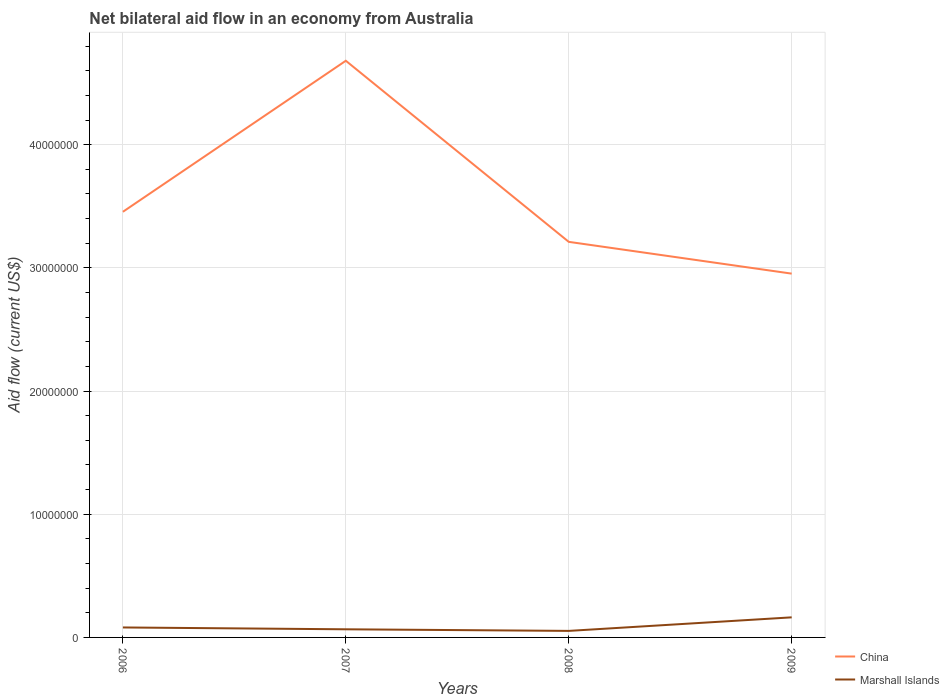Does the line corresponding to Marshall Islands intersect with the line corresponding to China?
Provide a short and direct response. No. Across all years, what is the maximum net bilateral aid flow in China?
Provide a short and direct response. 2.95e+07. What is the total net bilateral aid flow in Marshall Islands in the graph?
Make the answer very short. -1.10e+06. What is the difference between the highest and the second highest net bilateral aid flow in Marshall Islands?
Your response must be concise. 1.10e+06. How many lines are there?
Make the answer very short. 2. How many years are there in the graph?
Your answer should be compact. 4. What is the difference between two consecutive major ticks on the Y-axis?
Offer a very short reply. 1.00e+07. Does the graph contain any zero values?
Your response must be concise. No. How many legend labels are there?
Provide a succinct answer. 2. How are the legend labels stacked?
Your response must be concise. Vertical. What is the title of the graph?
Your response must be concise. Net bilateral aid flow in an economy from Australia. Does "Oman" appear as one of the legend labels in the graph?
Provide a short and direct response. No. What is the label or title of the X-axis?
Offer a terse response. Years. What is the Aid flow (current US$) of China in 2006?
Keep it short and to the point. 3.46e+07. What is the Aid flow (current US$) in Marshall Islands in 2006?
Keep it short and to the point. 8.10e+05. What is the Aid flow (current US$) in China in 2007?
Your answer should be very brief. 4.68e+07. What is the Aid flow (current US$) in Marshall Islands in 2007?
Offer a very short reply. 6.60e+05. What is the Aid flow (current US$) in China in 2008?
Provide a succinct answer. 3.21e+07. What is the Aid flow (current US$) in Marshall Islands in 2008?
Make the answer very short. 5.30e+05. What is the Aid flow (current US$) of China in 2009?
Your answer should be very brief. 2.95e+07. What is the Aid flow (current US$) of Marshall Islands in 2009?
Your answer should be very brief. 1.63e+06. Across all years, what is the maximum Aid flow (current US$) of China?
Your answer should be compact. 4.68e+07. Across all years, what is the maximum Aid flow (current US$) in Marshall Islands?
Keep it short and to the point. 1.63e+06. Across all years, what is the minimum Aid flow (current US$) of China?
Your response must be concise. 2.95e+07. Across all years, what is the minimum Aid flow (current US$) of Marshall Islands?
Give a very brief answer. 5.30e+05. What is the total Aid flow (current US$) in China in the graph?
Make the answer very short. 1.43e+08. What is the total Aid flow (current US$) in Marshall Islands in the graph?
Give a very brief answer. 3.63e+06. What is the difference between the Aid flow (current US$) of China in 2006 and that in 2007?
Your answer should be very brief. -1.23e+07. What is the difference between the Aid flow (current US$) of China in 2006 and that in 2008?
Give a very brief answer. 2.44e+06. What is the difference between the Aid flow (current US$) of Marshall Islands in 2006 and that in 2008?
Offer a very short reply. 2.80e+05. What is the difference between the Aid flow (current US$) of China in 2006 and that in 2009?
Give a very brief answer. 5.02e+06. What is the difference between the Aid flow (current US$) of Marshall Islands in 2006 and that in 2009?
Make the answer very short. -8.20e+05. What is the difference between the Aid flow (current US$) in China in 2007 and that in 2008?
Provide a short and direct response. 1.47e+07. What is the difference between the Aid flow (current US$) in Marshall Islands in 2007 and that in 2008?
Make the answer very short. 1.30e+05. What is the difference between the Aid flow (current US$) in China in 2007 and that in 2009?
Make the answer very short. 1.73e+07. What is the difference between the Aid flow (current US$) of Marshall Islands in 2007 and that in 2009?
Provide a short and direct response. -9.70e+05. What is the difference between the Aid flow (current US$) of China in 2008 and that in 2009?
Provide a succinct answer. 2.58e+06. What is the difference between the Aid flow (current US$) in Marshall Islands in 2008 and that in 2009?
Your answer should be very brief. -1.10e+06. What is the difference between the Aid flow (current US$) of China in 2006 and the Aid flow (current US$) of Marshall Islands in 2007?
Make the answer very short. 3.39e+07. What is the difference between the Aid flow (current US$) of China in 2006 and the Aid flow (current US$) of Marshall Islands in 2008?
Give a very brief answer. 3.40e+07. What is the difference between the Aid flow (current US$) of China in 2006 and the Aid flow (current US$) of Marshall Islands in 2009?
Offer a terse response. 3.29e+07. What is the difference between the Aid flow (current US$) in China in 2007 and the Aid flow (current US$) in Marshall Islands in 2008?
Your response must be concise. 4.63e+07. What is the difference between the Aid flow (current US$) of China in 2007 and the Aid flow (current US$) of Marshall Islands in 2009?
Your answer should be compact. 4.52e+07. What is the difference between the Aid flow (current US$) in China in 2008 and the Aid flow (current US$) in Marshall Islands in 2009?
Your answer should be very brief. 3.05e+07. What is the average Aid flow (current US$) in China per year?
Your answer should be very brief. 3.58e+07. What is the average Aid flow (current US$) of Marshall Islands per year?
Provide a short and direct response. 9.08e+05. In the year 2006, what is the difference between the Aid flow (current US$) in China and Aid flow (current US$) in Marshall Islands?
Keep it short and to the point. 3.37e+07. In the year 2007, what is the difference between the Aid flow (current US$) of China and Aid flow (current US$) of Marshall Islands?
Offer a very short reply. 4.62e+07. In the year 2008, what is the difference between the Aid flow (current US$) in China and Aid flow (current US$) in Marshall Islands?
Your response must be concise. 3.16e+07. In the year 2009, what is the difference between the Aid flow (current US$) of China and Aid flow (current US$) of Marshall Islands?
Your response must be concise. 2.79e+07. What is the ratio of the Aid flow (current US$) of China in 2006 to that in 2007?
Your answer should be compact. 0.74. What is the ratio of the Aid flow (current US$) in Marshall Islands in 2006 to that in 2007?
Offer a terse response. 1.23. What is the ratio of the Aid flow (current US$) of China in 2006 to that in 2008?
Give a very brief answer. 1.08. What is the ratio of the Aid flow (current US$) of Marshall Islands in 2006 to that in 2008?
Offer a terse response. 1.53. What is the ratio of the Aid flow (current US$) of China in 2006 to that in 2009?
Offer a terse response. 1.17. What is the ratio of the Aid flow (current US$) in Marshall Islands in 2006 to that in 2009?
Your response must be concise. 0.5. What is the ratio of the Aid flow (current US$) of China in 2007 to that in 2008?
Your response must be concise. 1.46. What is the ratio of the Aid flow (current US$) in Marshall Islands in 2007 to that in 2008?
Give a very brief answer. 1.25. What is the ratio of the Aid flow (current US$) of China in 2007 to that in 2009?
Your answer should be compact. 1.59. What is the ratio of the Aid flow (current US$) in Marshall Islands in 2007 to that in 2009?
Offer a very short reply. 0.4. What is the ratio of the Aid flow (current US$) in China in 2008 to that in 2009?
Your answer should be very brief. 1.09. What is the ratio of the Aid flow (current US$) in Marshall Islands in 2008 to that in 2009?
Give a very brief answer. 0.33. What is the difference between the highest and the second highest Aid flow (current US$) in China?
Your response must be concise. 1.23e+07. What is the difference between the highest and the second highest Aid flow (current US$) in Marshall Islands?
Provide a succinct answer. 8.20e+05. What is the difference between the highest and the lowest Aid flow (current US$) in China?
Keep it short and to the point. 1.73e+07. What is the difference between the highest and the lowest Aid flow (current US$) in Marshall Islands?
Provide a succinct answer. 1.10e+06. 